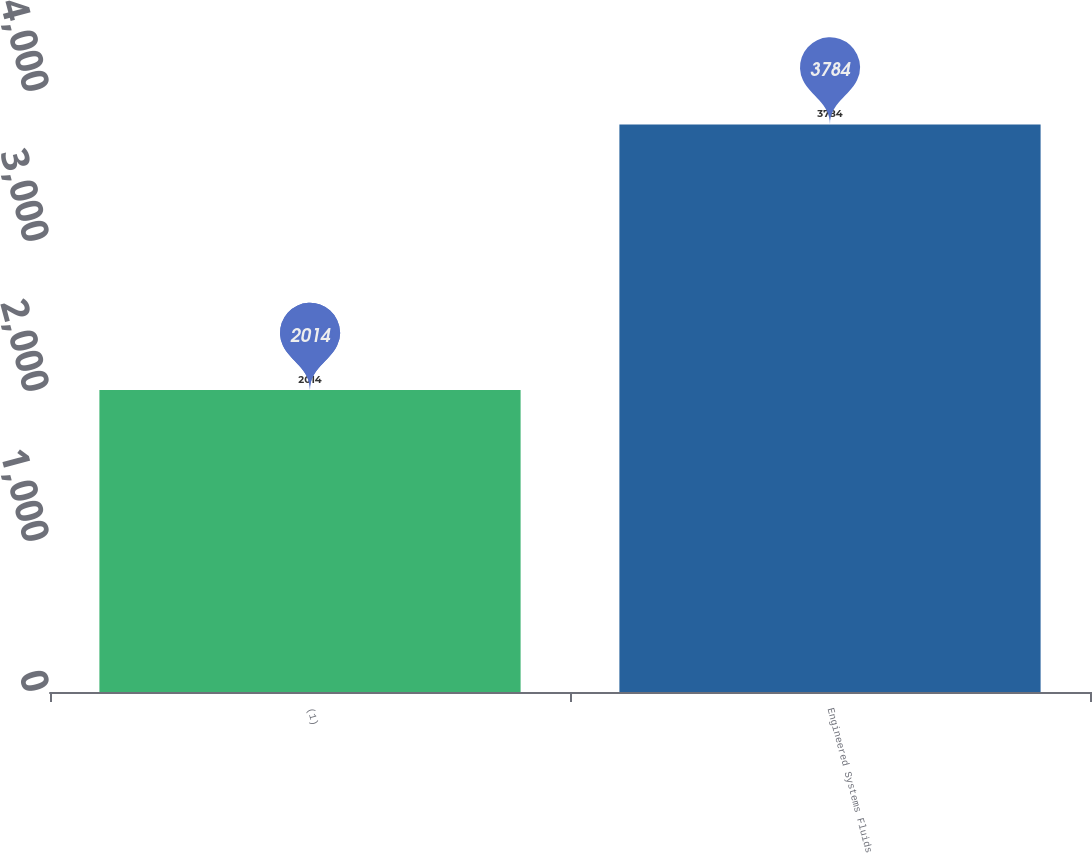<chart> <loc_0><loc_0><loc_500><loc_500><bar_chart><fcel>(1)<fcel>Engineered Systems Fluids<nl><fcel>2014<fcel>3784<nl></chart> 